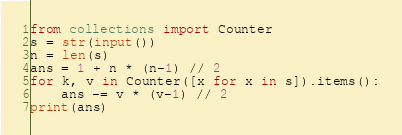<code> <loc_0><loc_0><loc_500><loc_500><_Python_>from collections import Counter
s = str(input())
n = len(s)
ans = 1 + n * (n-1) // 2
for k, v in Counter([x for x in s]).items():
    ans -= v * (v-1) // 2
print(ans)</code> 